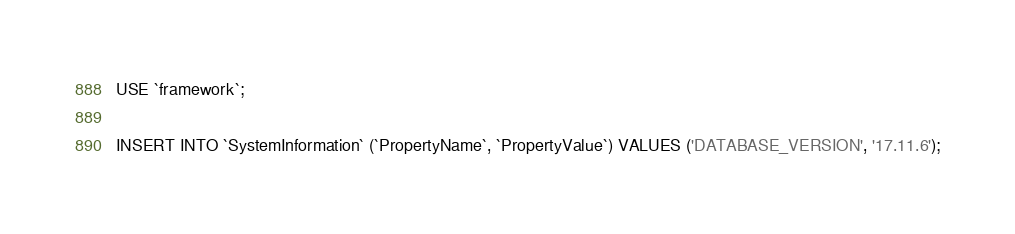Convert code to text. <code><loc_0><loc_0><loc_500><loc_500><_SQL_>USE `framework`;

INSERT INTO `SystemInformation` (`PropertyName`, `PropertyValue`) VALUES ('DATABASE_VERSION', '17.11.6');</code> 